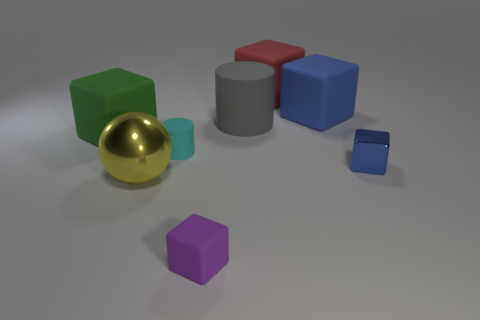There is a matte cube that is the same color as the tiny shiny cube; what is its size?
Provide a succinct answer. Large. Is there a large thing on the right side of the metallic object that is left of the blue object that is to the left of the small blue block?
Give a very brief answer. Yes. Are there any purple rubber things behind the big blue rubber block?
Provide a short and direct response. No. What number of big rubber cylinders are behind the matte cylinder that is in front of the big gray cylinder?
Keep it short and to the point. 1. There is a green matte object; does it have the same size as the cylinder that is on the right side of the tiny cyan rubber thing?
Provide a succinct answer. Yes. Are there any other big matte cylinders that have the same color as the large cylinder?
Give a very brief answer. No. The blue thing that is made of the same material as the big green object is what size?
Provide a short and direct response. Large. Is the tiny blue object made of the same material as the green thing?
Provide a short and direct response. No. There is a shiny object that is on the right side of the large matte cube that is behind the blue object that is behind the small blue thing; what is its color?
Offer a terse response. Blue. What shape is the small cyan rubber object?
Make the answer very short. Cylinder. 